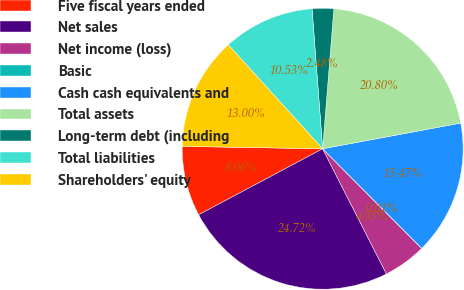<chart> <loc_0><loc_0><loc_500><loc_500><pie_chart><fcel>Five fiscal years ended<fcel>Net sales<fcel>Net income (loss)<fcel>Basic<fcel>Cash cash equivalents and<fcel>Total assets<fcel>Long-term debt (including<fcel>Total liabilities<fcel>Shareholders' equity<nl><fcel>8.06%<fcel>24.72%<fcel>4.95%<fcel>0.01%<fcel>15.47%<fcel>20.8%<fcel>2.48%<fcel>10.53%<fcel>13.0%<nl></chart> 